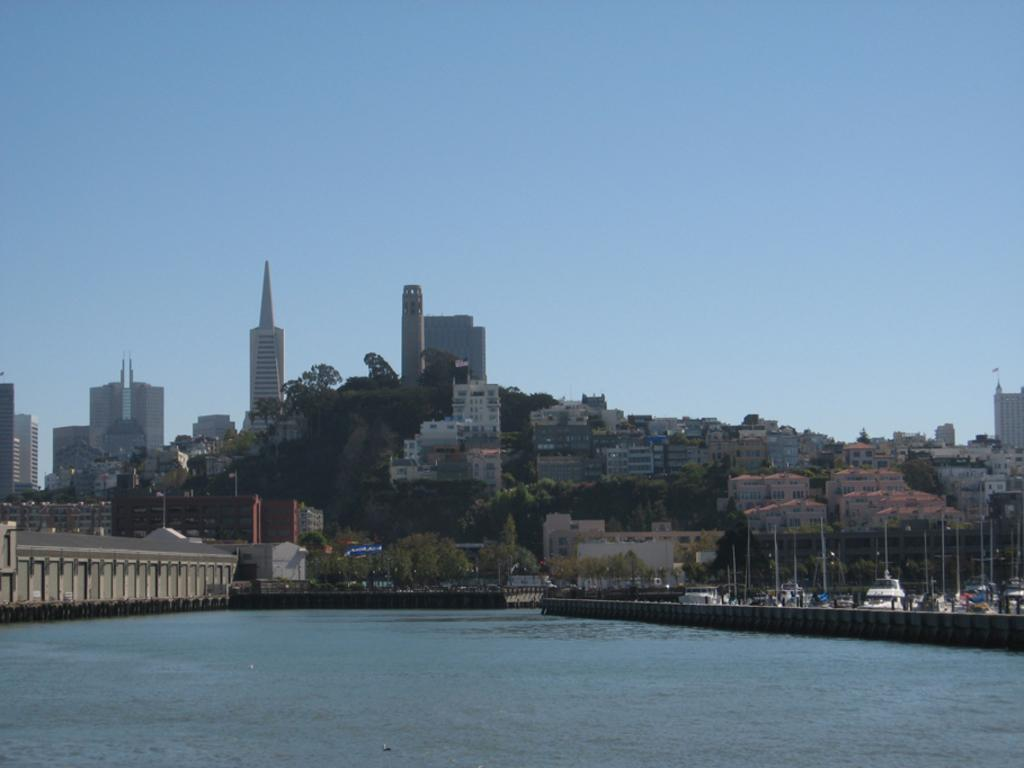What type of structures are visible in the image? There is a group of buildings with windows in the image. What natural feature can be seen in the image? There is a water body in the image. What type of vegetation is present in the image? Trees are present in the image. What man-made objects can be seen in the image? Poles are visible in the image. How would you describe the weather in the image? The sky is cloudy in the image. How many lumber pieces can be seen floating in the water body in the image? There is no mention of lumber in the image, so it cannot be determined if any lumber pieces are present. Can you spot a tiger hiding among the trees in the image? There is no tiger present in the image; only trees are mentioned. 